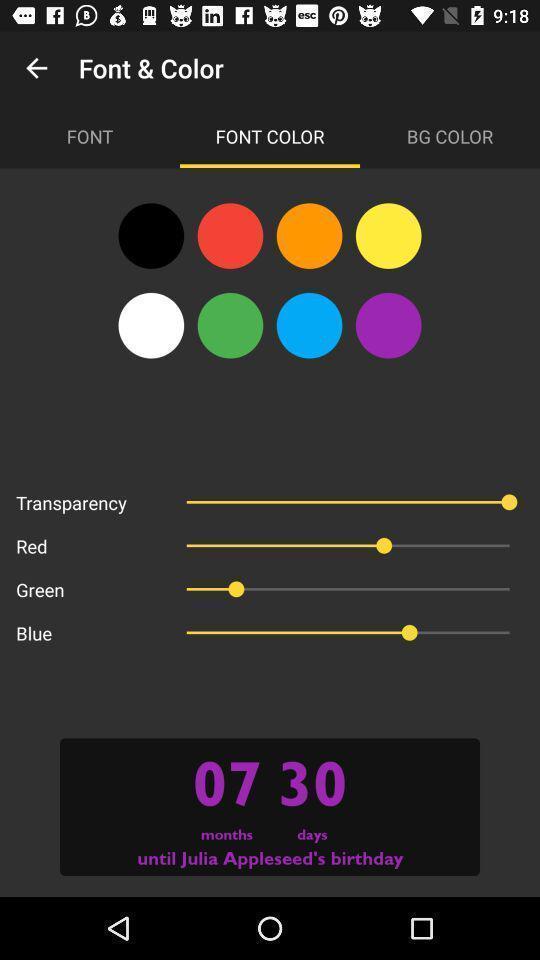Give me a summary of this screen capture. Settings page with different font and color options. 